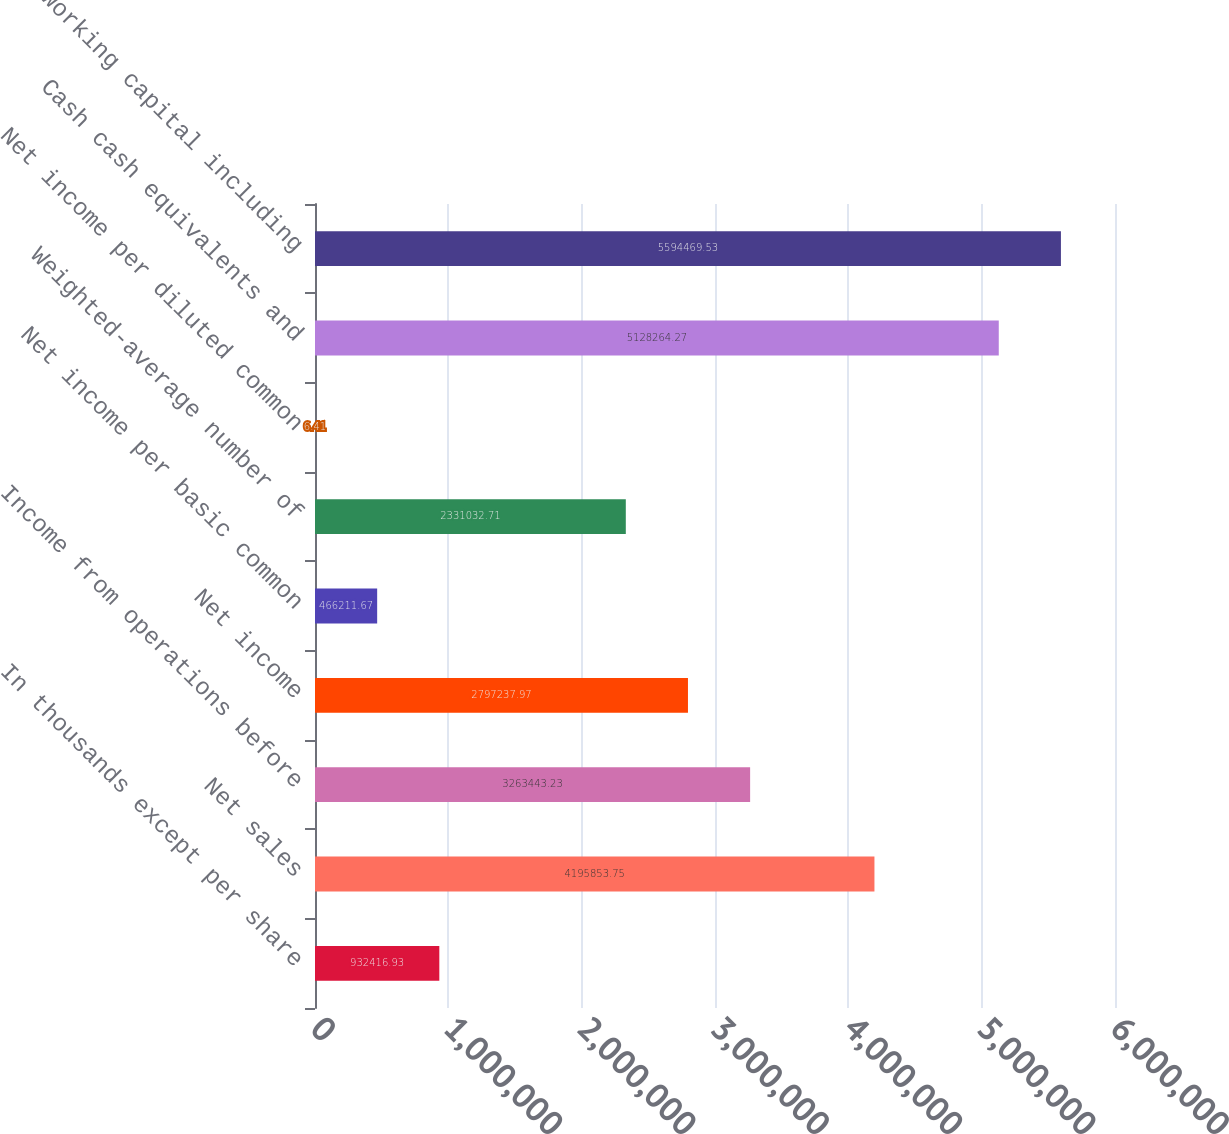<chart> <loc_0><loc_0><loc_500><loc_500><bar_chart><fcel>In thousands except per share<fcel>Net sales<fcel>Income from operations before<fcel>Net income<fcel>Net income per basic common<fcel>Weighted-average number of<fcel>Net income per diluted common<fcel>Cash cash equivalents and<fcel>Working capital including<nl><fcel>932417<fcel>4.19585e+06<fcel>3.26344e+06<fcel>2.79724e+06<fcel>466212<fcel>2.33103e+06<fcel>6.41<fcel>5.12826e+06<fcel>5.59447e+06<nl></chart> 